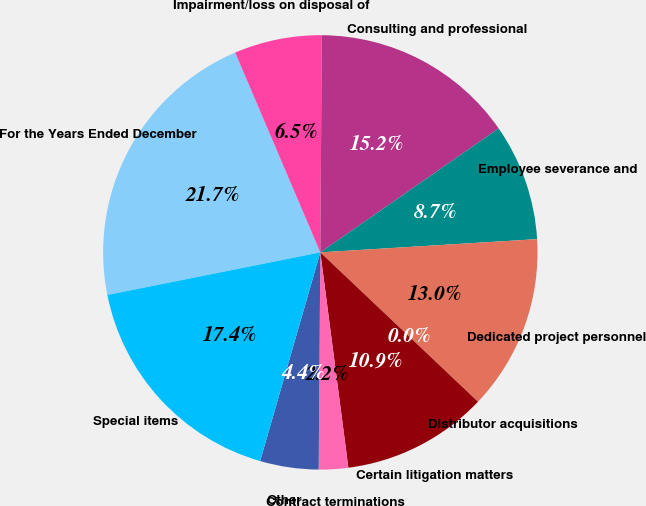Convert chart. <chart><loc_0><loc_0><loc_500><loc_500><pie_chart><fcel>For the Years Ended December<fcel>Impairment/loss on disposal of<fcel>Consulting and professional<fcel>Employee severance and<fcel>Dedicated project personnel<fcel>Distributor acquisitions<fcel>Certain litigation matters<fcel>Contract terminations<fcel>Other<fcel>Special items<nl><fcel>21.73%<fcel>6.52%<fcel>15.22%<fcel>8.7%<fcel>13.04%<fcel>0.0%<fcel>10.87%<fcel>2.18%<fcel>4.35%<fcel>17.39%<nl></chart> 